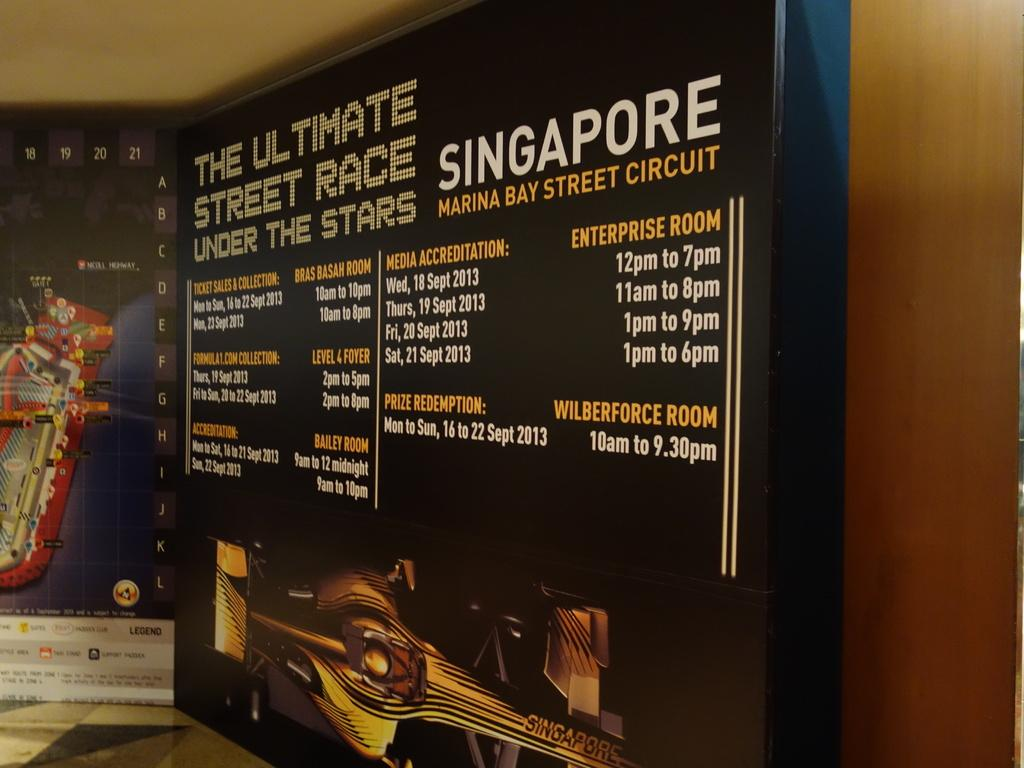<image>
Share a concise interpretation of the image provided. A schedule of the ultimate street race under stars in Singapore. 